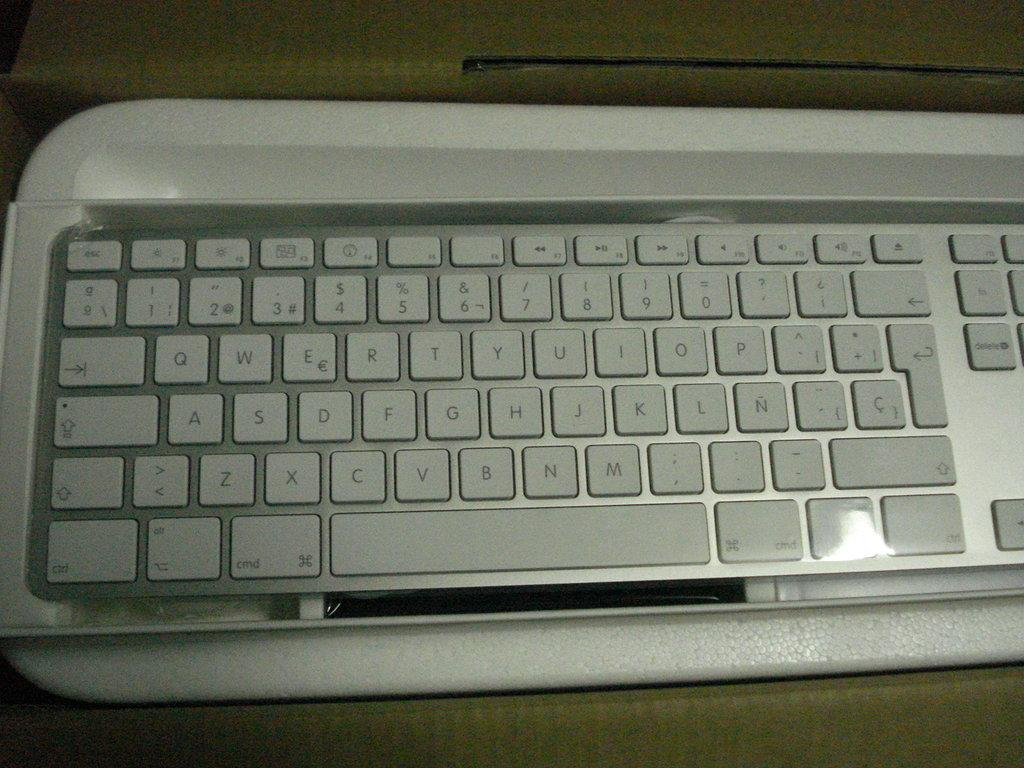<image>
Relay a brief, clear account of the picture shown. A white computer keyboard has function keys like "Ctrl" and "Cmd". 